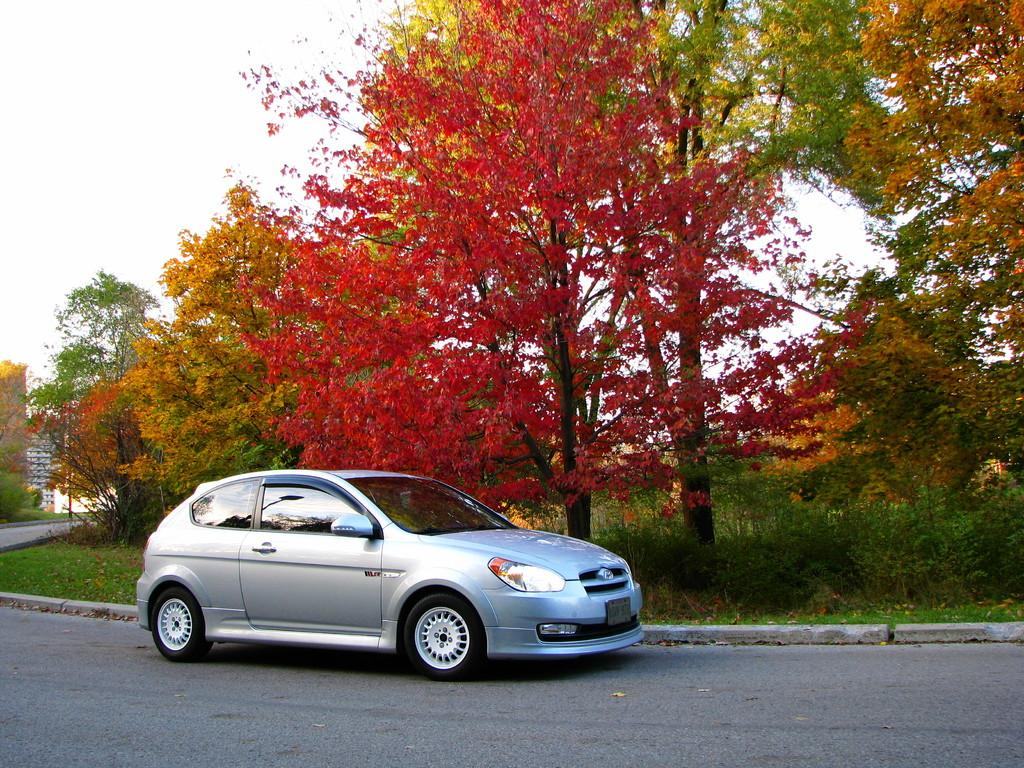What is the main feature of the image? There is a road in the image. What is on the road? A car is visible on the road. What can be seen in the background of the image? There is grass and trees in the background of the image. What month is it in the image? The month cannot be determined from the image, as there is no information about the time of year. How many legs can be seen on the car in the image? Cars do not have legs; they have wheels. In the image, the car has four wheels. 